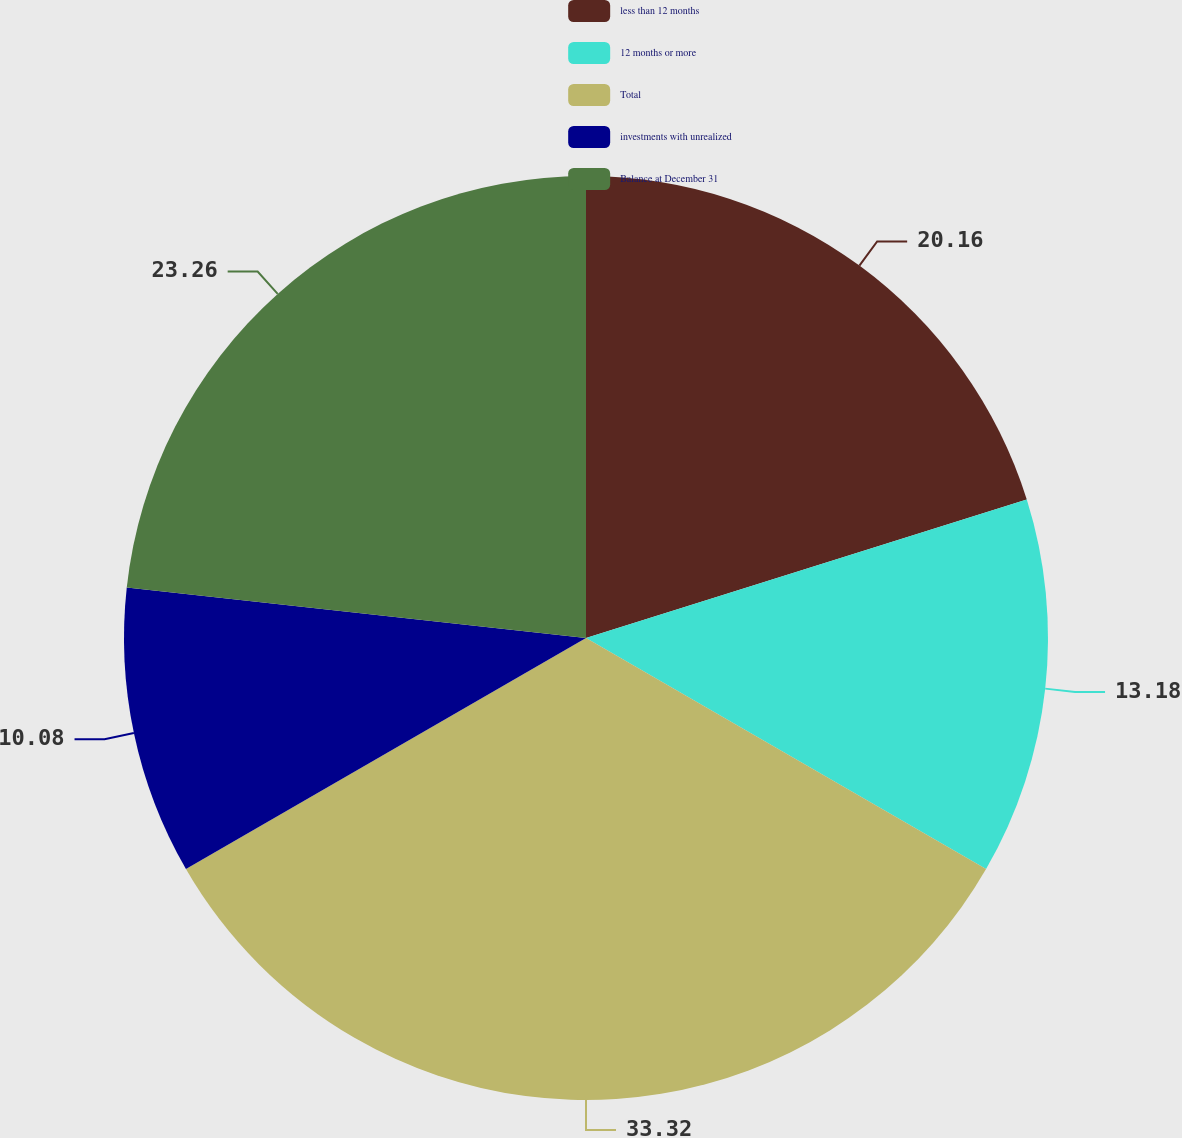Convert chart to OTSL. <chart><loc_0><loc_0><loc_500><loc_500><pie_chart><fcel>less than 12 months<fcel>12 months or more<fcel>Total<fcel>investments with unrealized<fcel>Balance at December 31<nl><fcel>20.16%<fcel>13.18%<fcel>33.33%<fcel>10.08%<fcel>23.26%<nl></chart> 